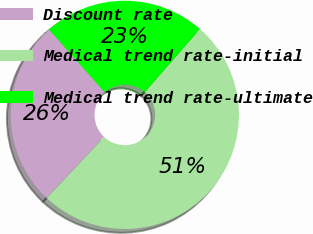Convert chart. <chart><loc_0><loc_0><loc_500><loc_500><pie_chart><fcel>Discount rate<fcel>Medical trend rate-initial<fcel>Medical trend rate-ultimate<nl><fcel>26.44%<fcel>50.57%<fcel>22.99%<nl></chart> 